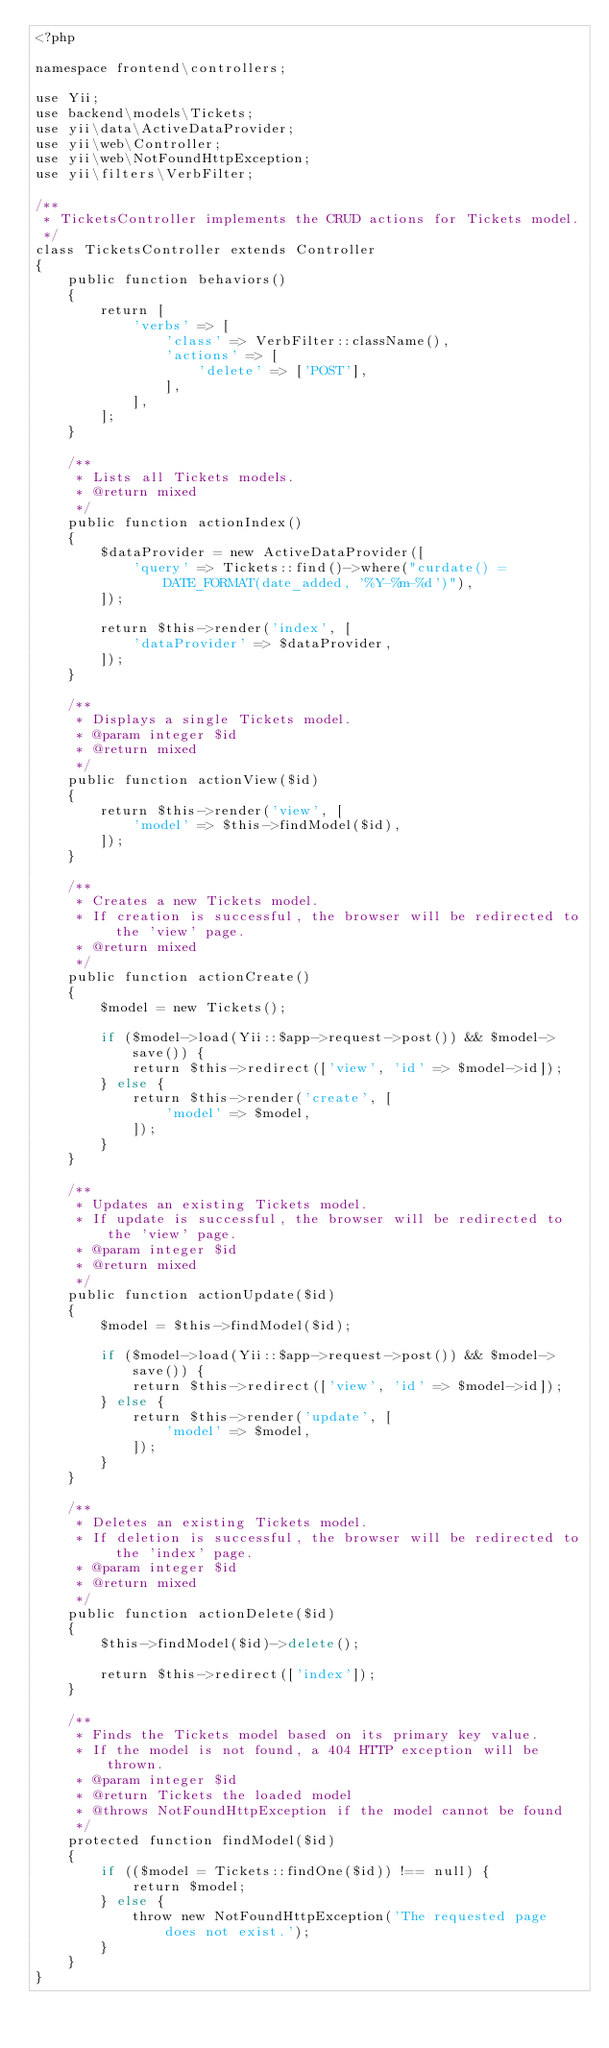Convert code to text. <code><loc_0><loc_0><loc_500><loc_500><_PHP_><?php

namespace frontend\controllers;

use Yii;
use backend\models\Tickets;
use yii\data\ActiveDataProvider;
use yii\web\Controller;
use yii\web\NotFoundHttpException;
use yii\filters\VerbFilter;

/**
 * TicketsController implements the CRUD actions for Tickets model.
 */
class TicketsController extends Controller
{
    public function behaviors()
    {
        return [
            'verbs' => [
                'class' => VerbFilter::className(),
                'actions' => [
                    'delete' => ['POST'],
                ],
            ],
        ];
    }

    /**
     * Lists all Tickets models.
     * @return mixed
     */
    public function actionIndex()
    {
        $dataProvider = new ActiveDataProvider([
            'query' => Tickets::find()->where("curdate() = DATE_FORMAT(date_added, '%Y-%m-%d')"),
        ]);

        return $this->render('index', [
            'dataProvider' => $dataProvider,
        ]);
    }

    /**
     * Displays a single Tickets model.
     * @param integer $id
     * @return mixed
     */
    public function actionView($id)
    {
        return $this->render('view', [
            'model' => $this->findModel($id),
        ]);
    }

    /**
     * Creates a new Tickets model.
     * If creation is successful, the browser will be redirected to the 'view' page.
     * @return mixed
     */
    public function actionCreate()
    {
        $model = new Tickets();

        if ($model->load(Yii::$app->request->post()) && $model->save()) {
            return $this->redirect(['view', 'id' => $model->id]);
        } else {
            return $this->render('create', [
                'model' => $model,
            ]);
        }
    }

    /**
     * Updates an existing Tickets model.
     * If update is successful, the browser will be redirected to the 'view' page.
     * @param integer $id
     * @return mixed
     */
    public function actionUpdate($id)
    {
        $model = $this->findModel($id);

        if ($model->load(Yii::$app->request->post()) && $model->save()) {
            return $this->redirect(['view', 'id' => $model->id]);
        } else {
            return $this->render('update', [
                'model' => $model,
            ]);
        }
    }

    /**
     * Deletes an existing Tickets model.
     * If deletion is successful, the browser will be redirected to the 'index' page.
     * @param integer $id
     * @return mixed
     */
    public function actionDelete($id)
    {
        $this->findModel($id)->delete();

        return $this->redirect(['index']);
    }

    /**
     * Finds the Tickets model based on its primary key value.
     * If the model is not found, a 404 HTTP exception will be thrown.
     * @param integer $id
     * @return Tickets the loaded model
     * @throws NotFoundHttpException if the model cannot be found
     */
    protected function findModel($id)
    {
        if (($model = Tickets::findOne($id)) !== null) {
            return $model;
        } else {
            throw new NotFoundHttpException('The requested page does not exist.');
        }
    }
}
</code> 